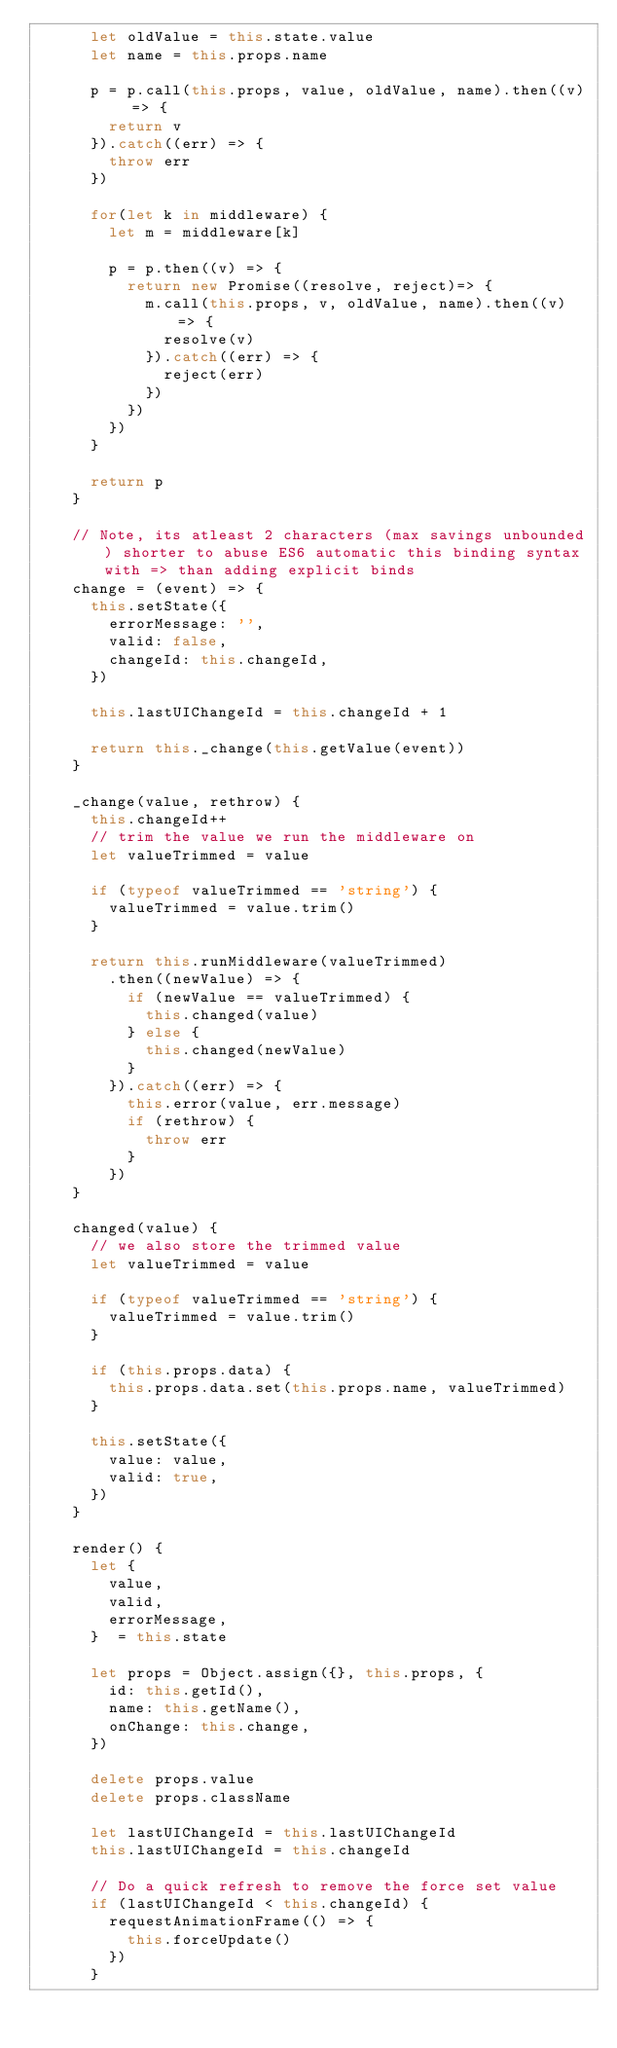<code> <loc_0><loc_0><loc_500><loc_500><_JavaScript_>      let oldValue = this.state.value
      let name = this.props.name

      p = p.call(this.props, value, oldValue, name).then((v) => {
        return v
      }).catch((err) => {
        throw err
      })

      for(let k in middleware) {
        let m = middleware[k]

        p = p.then((v) => {
          return new Promise((resolve, reject)=> {
            m.call(this.props, v, oldValue, name).then((v) => {
              resolve(v)
            }).catch((err) => {
              reject(err)
            })
          })
        })
      }

      return p
    }

    // Note, its atleast 2 characters (max savings unbounded) shorter to abuse ES6 automatic this binding syntax with => than adding explicit binds
    change = (event) => {
      this.setState({
        errorMessage: '',
        valid: false,
        changeId: this.changeId,
      })

      this.lastUIChangeId = this.changeId + 1

      return this._change(this.getValue(event))
    }

    _change(value, rethrow) {
      this.changeId++
      // trim the value we run the middleware on
      let valueTrimmed = value

      if (typeof valueTrimmed == 'string') {
        valueTrimmed = value.trim()
      }

      return this.runMiddleware(valueTrimmed)
        .then((newValue) => {
          if (newValue == valueTrimmed) {
            this.changed(value)
          } else {
            this.changed(newValue)
          }
        }).catch((err) => {
          this.error(value, err.message)
          if (rethrow) {
            throw err
          }
        })
    }

    changed(value) {
      // we also store the trimmed value
      let valueTrimmed = value

      if (typeof valueTrimmed == 'string') {
        valueTrimmed = value.trim()
      }

      if (this.props.data) {
        this.props.data.set(this.props.name, valueTrimmed)
      }

      this.setState({
        value: value,
        valid: true,
      })
    }

    render() {
      let {
        value,
        valid,
        errorMessage,
      }  = this.state

      let props = Object.assign({}, this.props, {
        id: this.getId(),
        name: this.getName(),
        onChange: this.change,
      })

      delete props.value
      delete props.className

      let lastUIChangeId = this.lastUIChangeId
      this.lastUIChangeId = this.changeId

      // Do a quick refresh to remove the force set value
      if (lastUIChangeId < this.changeId) {
        requestAnimationFrame(() => {
          this.forceUpdate()
        })
      }
</code> 